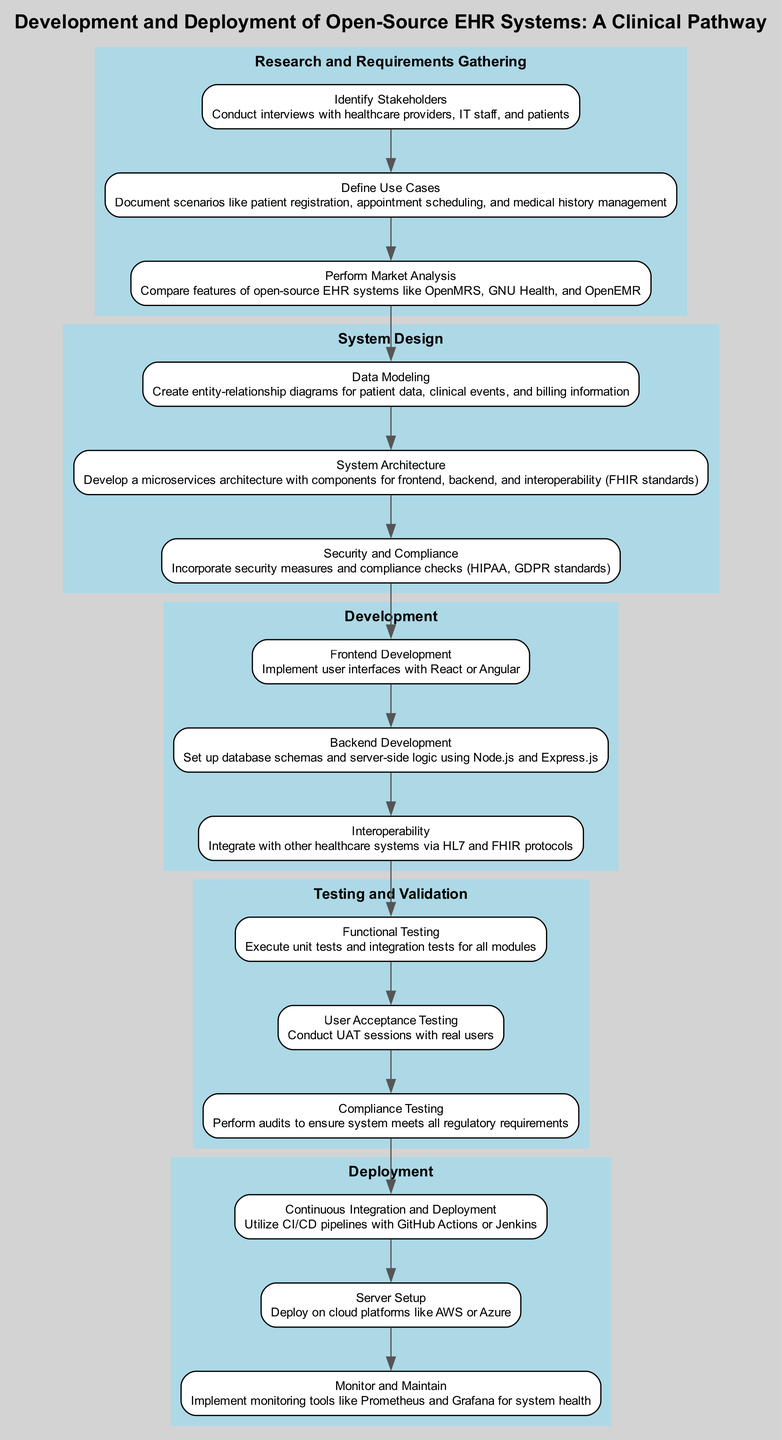What is the first step in the clinical pathway? The first step in the clinical pathway is "Research and Requirements Gathering." This can be identified by looking at the first cluster at the top of the diagram.
Answer: Research and Requirements Gathering How many actions are there in the "System Design" step? In the "System Design" step, there are three actions. They are related to data modeling, system architecture, and security/compliance. This can be counted by examining the number of individual actions listed in that step.
Answer: 3 What is the last action in the "Deployment" step? The last action in the "Deployment" step is "Monitor and Maintain." This is derived from observing the last box in that cluster labeled with that action name.
Answer: Monitor and Maintain Which two steps are directly connected? The "Development" step is directly connected to the "Testing and Validation" step. The flow between these steps can be traced by following the arrow linking the last action in "Development" to the first action in "Testing and Validation."
Answer: Development and Testing and Validation What protocols are mentioned under the "Interoperability" action? The protocols mentioned under the "Interoperability" action are "HL7 and FHIR." This information can be found in the details provided for that specific action within the diagram.
Answer: HL7 and FHIR What are the names of actions involved in "Testing and Validation"? The actions involved in "Testing and Validation" are "Functional Testing," "User Acceptance Testing," and "Compliance Testing." This can be confirmed by listing all actions within that specific step.
Answer: Functional Testing, User Acceptance Testing, Compliance Testing Which step includes "Security and Compliance"? "Security and Compliance" is included in the "System Design" step. This can be identified by locating that specific action within the corresponding cluster labeled "System Design."
Answer: System Design How many total steps are there in the clinical pathway? There are five steps in the clinical pathway: "Research and Requirements Gathering," "System Design," "Development," "Testing and Validation," and "Deployment." Counting these steps in the diagram confirms the total number.
Answer: 5 What is a key focus of the "Research and Requirements Gathering" step? A key focus of the "Research and Requirements Gathering" step is to "Define Use Cases." This is identified as one of the specific actions listed under that step.
Answer: Define Use Cases 